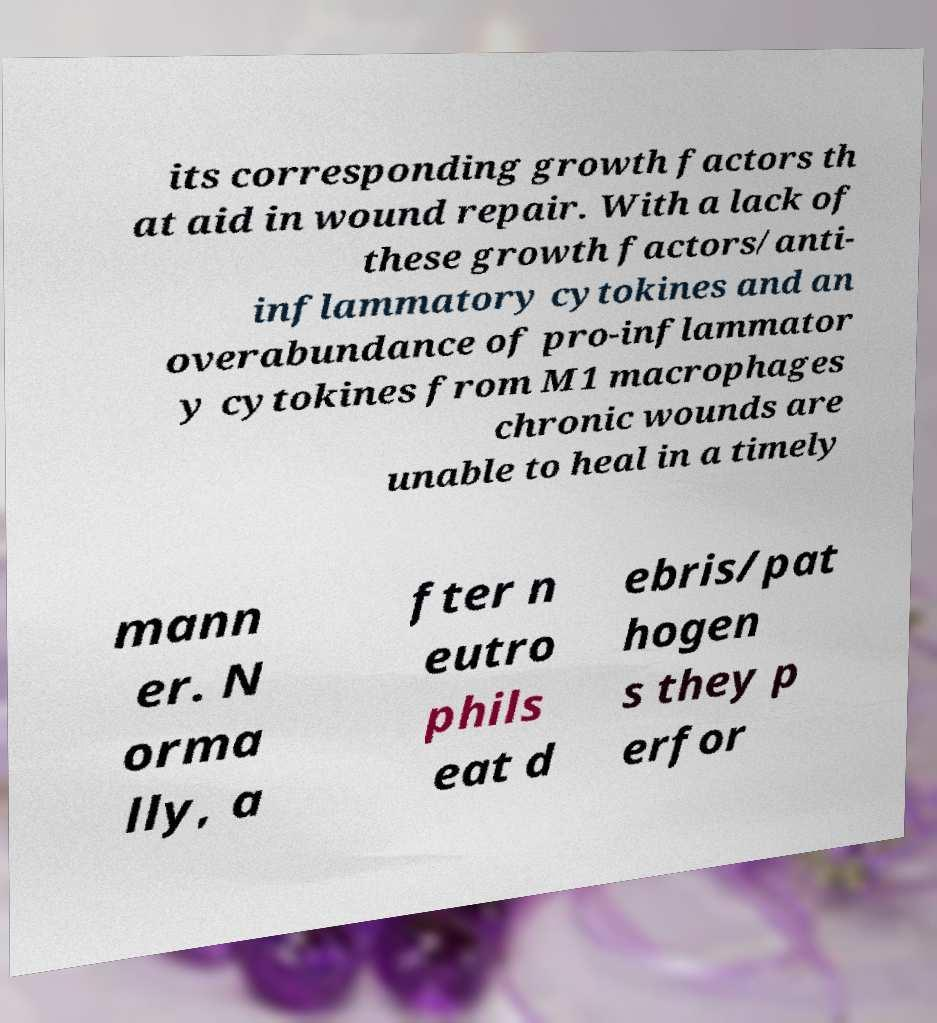Please read and relay the text visible in this image. What does it say? its corresponding growth factors th at aid in wound repair. With a lack of these growth factors/anti- inflammatory cytokines and an overabundance of pro-inflammator y cytokines from M1 macrophages chronic wounds are unable to heal in a timely mann er. N orma lly, a fter n eutro phils eat d ebris/pat hogen s they p erfor 